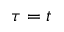<formula> <loc_0><loc_0><loc_500><loc_500>\tau = t</formula> 